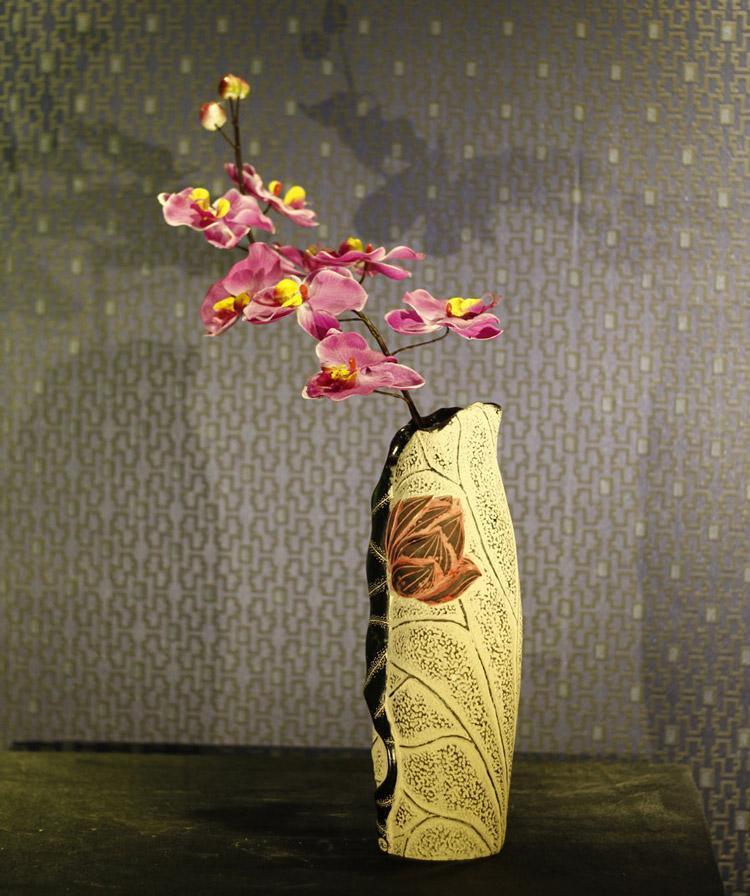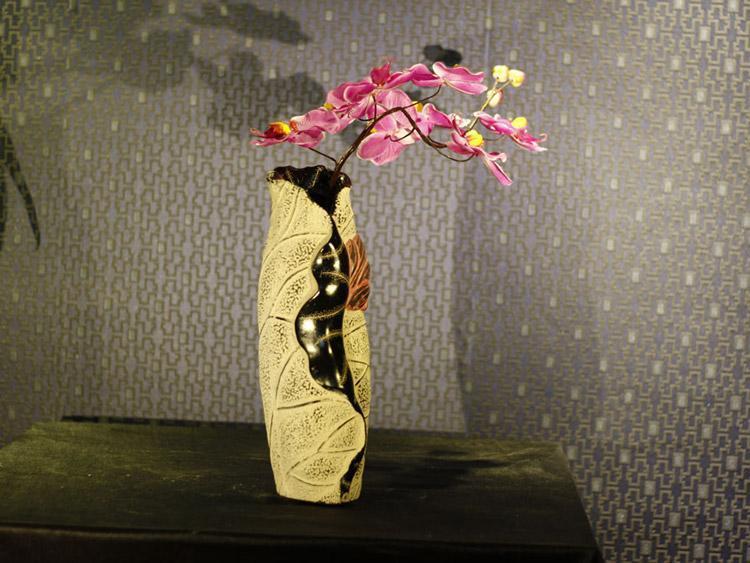The first image is the image on the left, the second image is the image on the right. For the images displayed, is the sentence "Floral arrangements are in all vases." factually correct? Answer yes or no. Yes. 